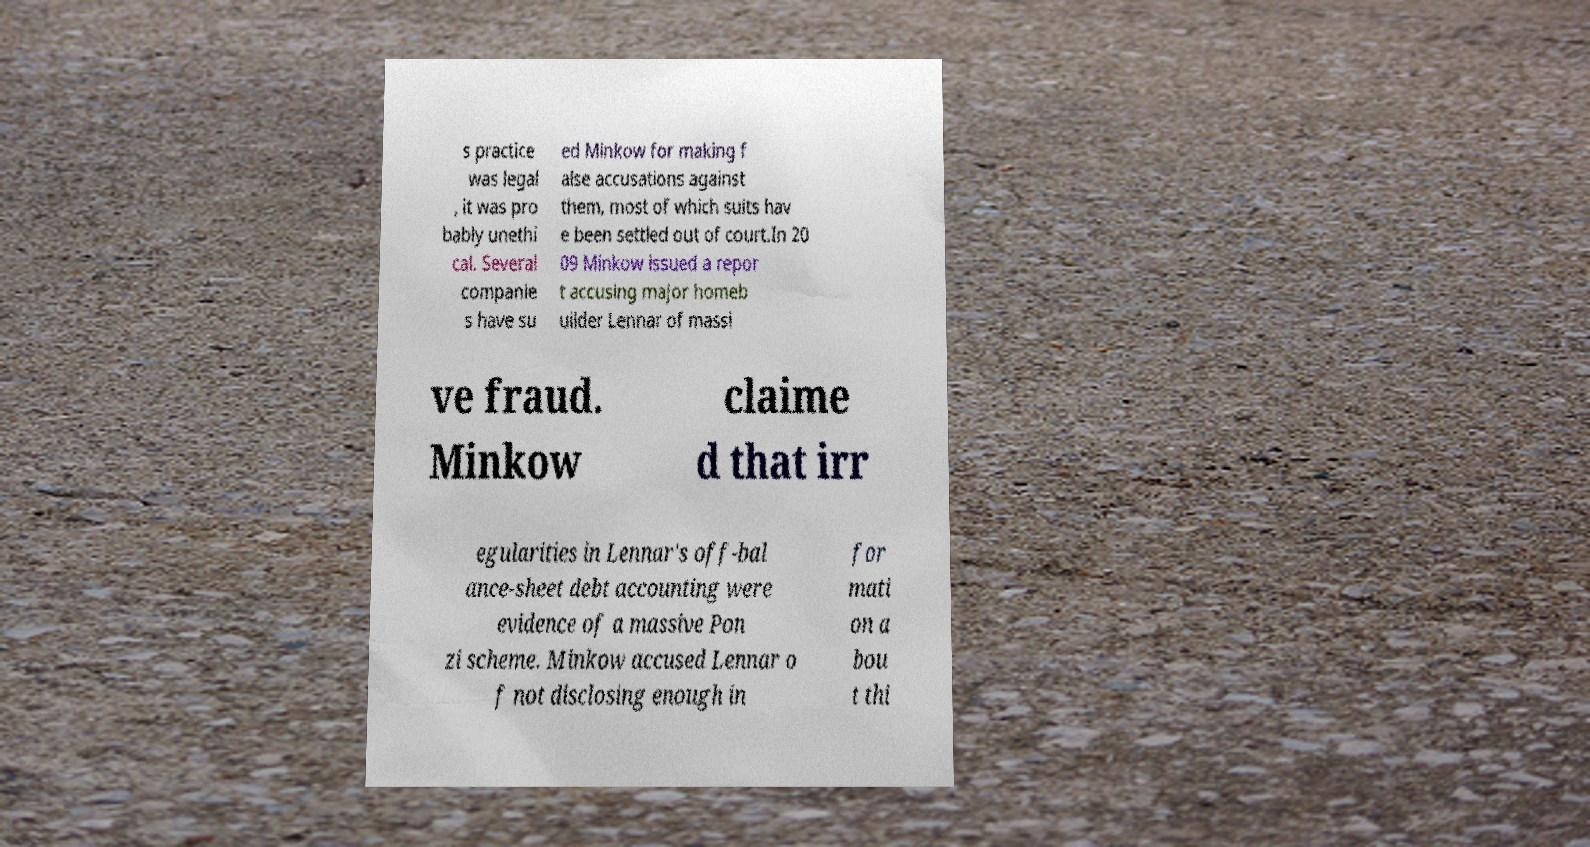Could you extract and type out the text from this image? s practice was legal , it was pro bably unethi cal. Several companie s have su ed Minkow for making f alse accusations against them, most of which suits hav e been settled out of court.In 20 09 Minkow issued a repor t accusing major homeb uilder Lennar of massi ve fraud. Minkow claime d that irr egularities in Lennar's off-bal ance-sheet debt accounting were evidence of a massive Pon zi scheme. Minkow accused Lennar o f not disclosing enough in for mati on a bou t thi 